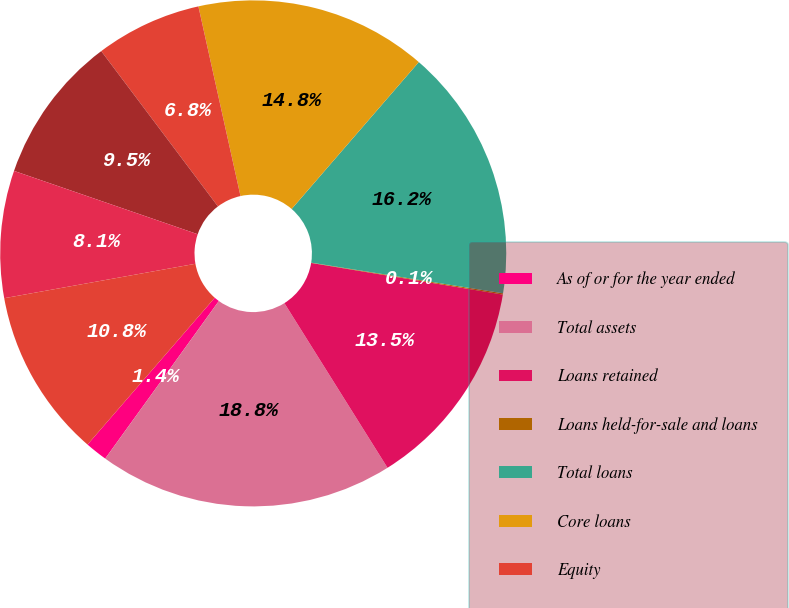Convert chart. <chart><loc_0><loc_0><loc_500><loc_500><pie_chart><fcel>As of or for the year ended<fcel>Total assets<fcel>Loans retained<fcel>Loans held-for-sale and loans<fcel>Total loans<fcel>Core loans<fcel>Equity<fcel>Middle Market Banking (a)<fcel>Corporate Client Banking (a)<fcel>Commercial Term Lending<nl><fcel>1.42%<fcel>18.85%<fcel>13.49%<fcel>0.08%<fcel>16.17%<fcel>14.83%<fcel>6.78%<fcel>9.46%<fcel>8.12%<fcel>10.8%<nl></chart> 